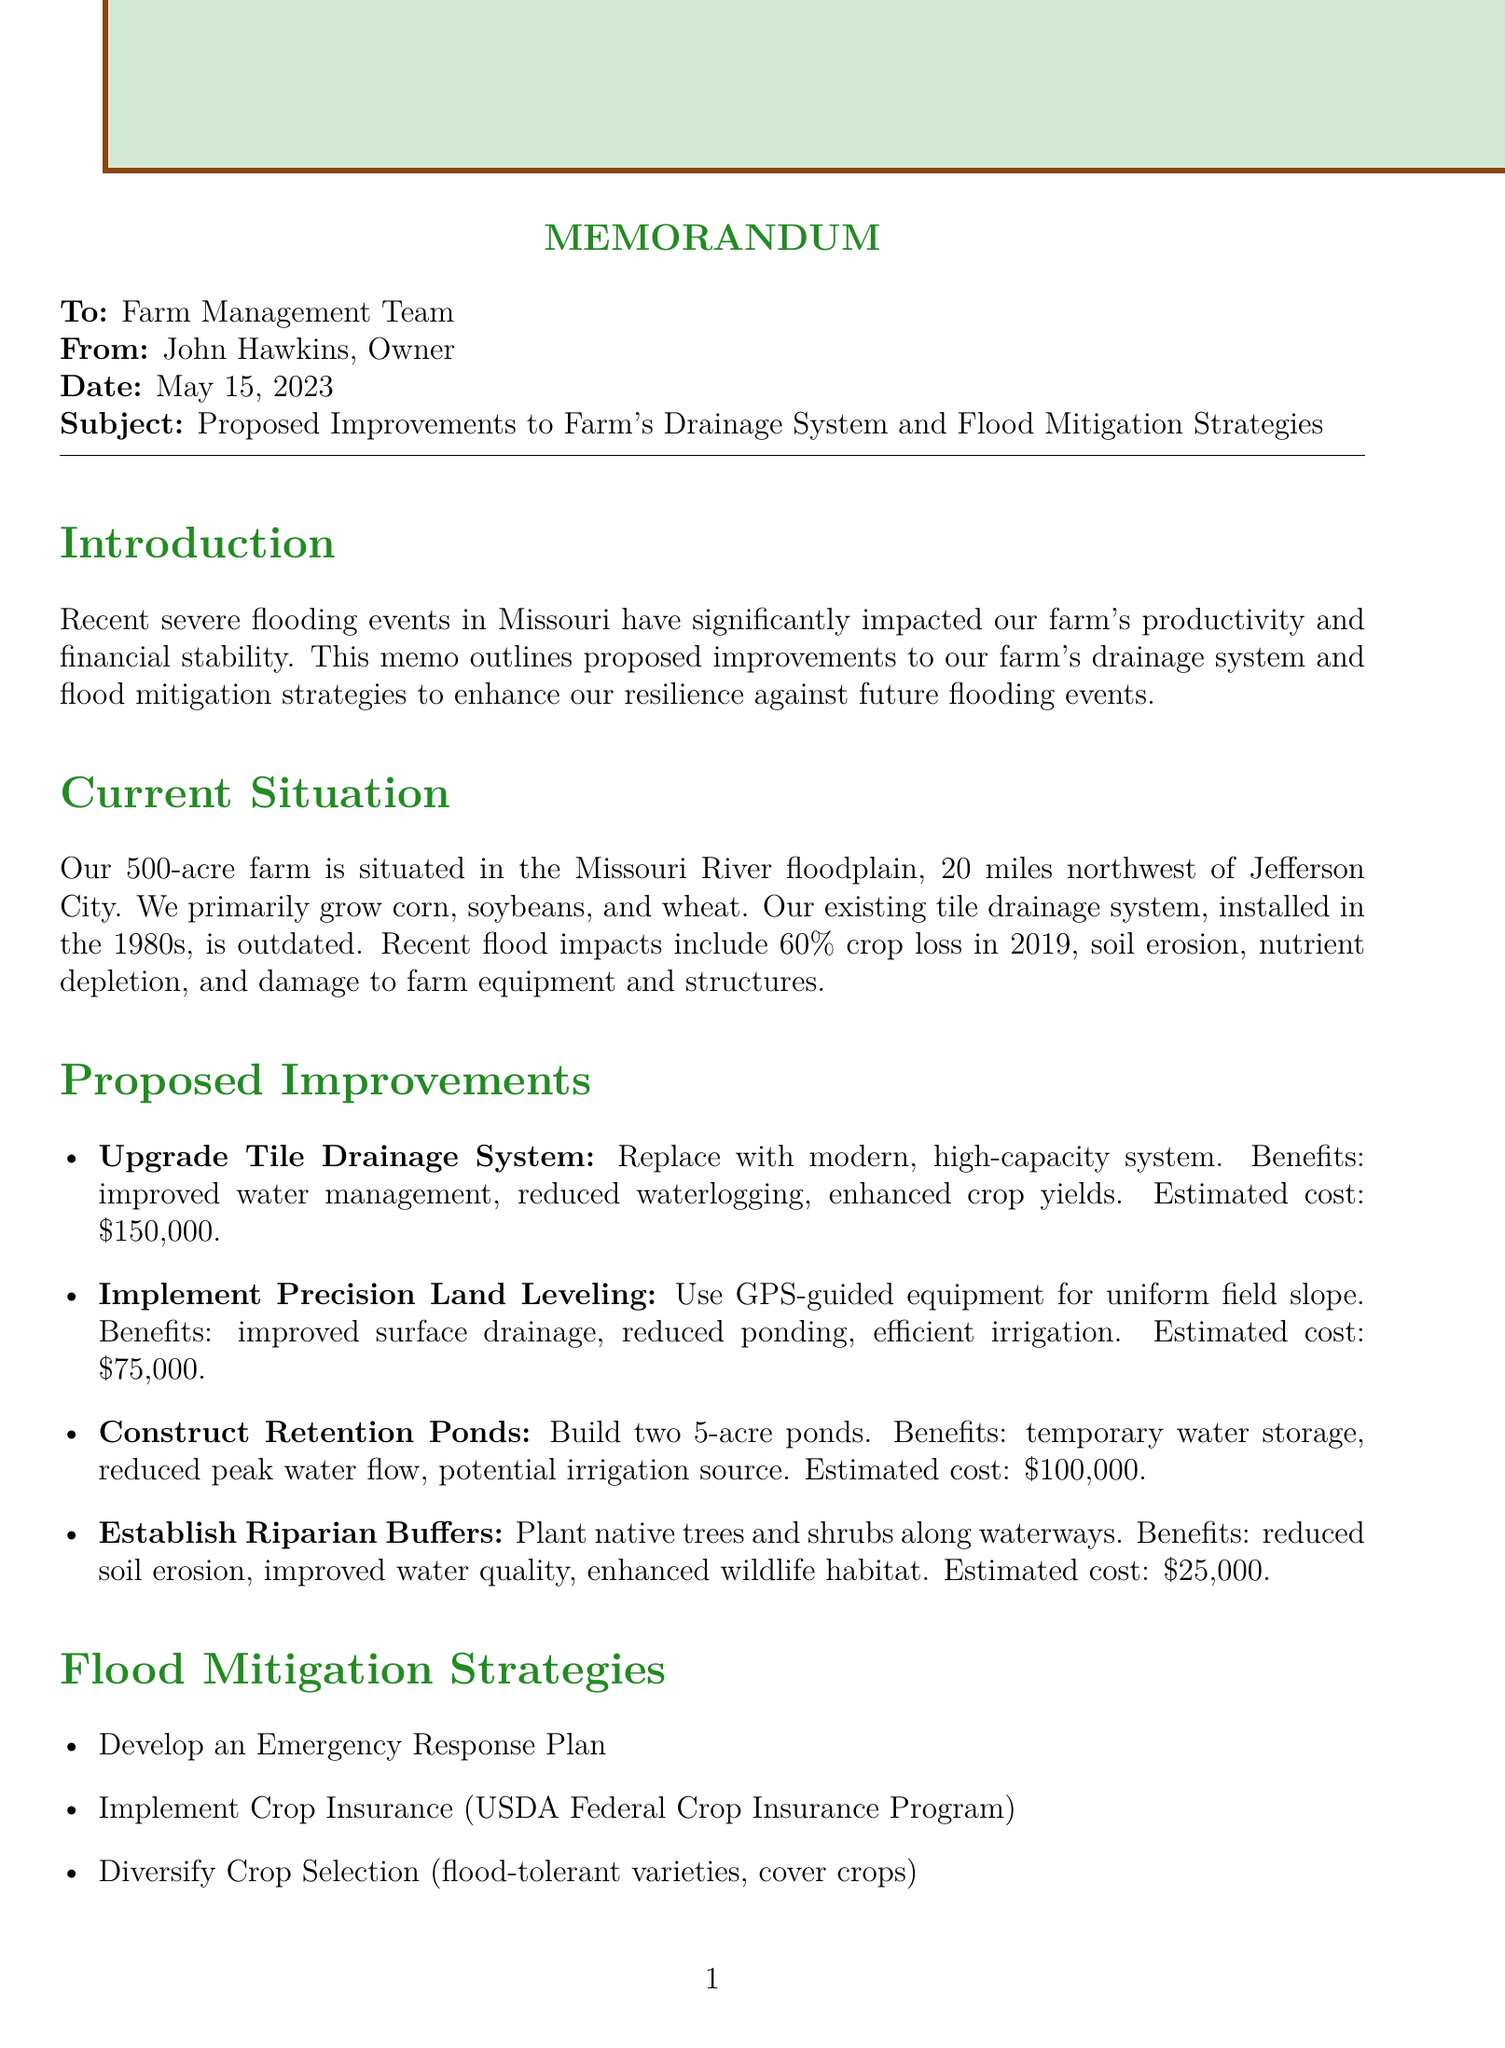what is the date of the memo? The date of the memo is clearly stated in the header section of the document.
Answer: May 15, 2023 how many acres is the farm? The size of the farm is mentioned in the current situation section of the document.
Answer: 500 acres what is the estimated cost for upgrading the tile drainage system? The estimated cost for this specific improvement is listed in the proposed improvements section.
Answer: $150,000 what is one of the proposed crop selections for diversification? The document lists specific crop varieties that are recommended for diversification in the flood mitigation strategies section.
Answer: flood-tolerant soybean varieties how long is the implementation phase for planning and design? The duration for this phase is mentioned in the implementation timeline section.
Answer: 3 months which department provides cost-share grants for approved practices? The funding sources section specifically mentions this department and its associated program.
Answer: Missouri Department of Natural Resources what is one benefit of establishing riparian buffers? The benefits of this improvement are outlined in the proposed improvements section of the memo.
Answer: Improved water quality what is a key element of the emergency response plan? The document outlines several key elements in the flood mitigation strategies section.
Answer: Early warning system integration 